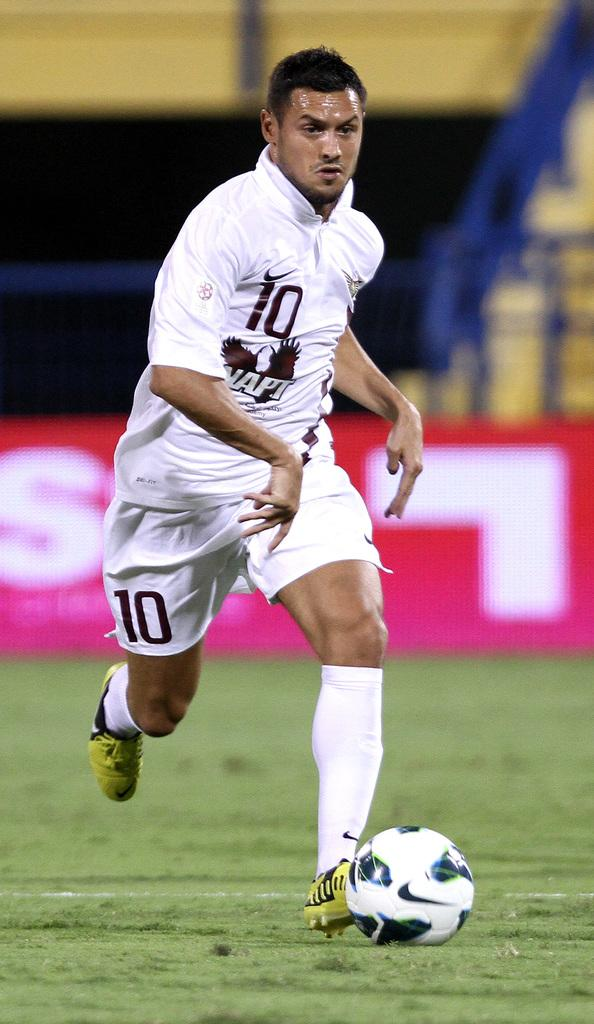<image>
Provide a brief description of the given image. Man wearing a white jersey with the number 10 on it. 